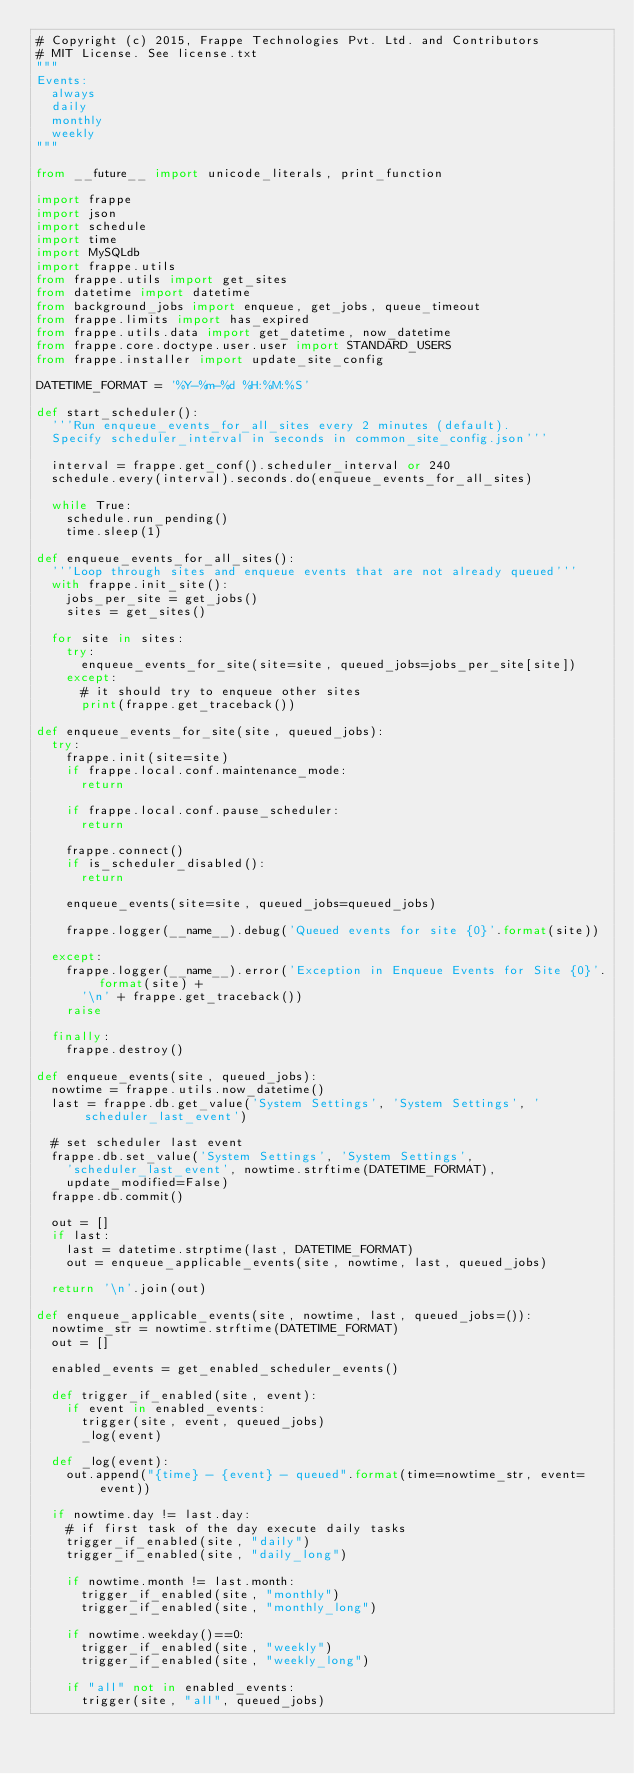<code> <loc_0><loc_0><loc_500><loc_500><_Python_># Copyright (c) 2015, Frappe Technologies Pvt. Ltd. and Contributors
# MIT License. See license.txt
"""
Events:
	always
	daily
	monthly
	weekly
"""

from __future__ import unicode_literals, print_function

import frappe
import json
import schedule
import time
import MySQLdb
import frappe.utils
from frappe.utils import get_sites
from datetime import datetime
from background_jobs import enqueue, get_jobs, queue_timeout
from frappe.limits import has_expired
from frappe.utils.data import get_datetime, now_datetime
from frappe.core.doctype.user.user import STANDARD_USERS
from frappe.installer import update_site_config

DATETIME_FORMAT = '%Y-%m-%d %H:%M:%S'

def start_scheduler():
	'''Run enqueue_events_for_all_sites every 2 minutes (default).
	Specify scheduler_interval in seconds in common_site_config.json'''

	interval = frappe.get_conf().scheduler_interval or 240
	schedule.every(interval).seconds.do(enqueue_events_for_all_sites)

	while True:
		schedule.run_pending()
		time.sleep(1)

def enqueue_events_for_all_sites():
	'''Loop through sites and enqueue events that are not already queued'''
	with frappe.init_site():
		jobs_per_site = get_jobs()
		sites = get_sites()

	for site in sites:
		try:
			enqueue_events_for_site(site=site, queued_jobs=jobs_per_site[site])
		except:
			# it should try to enqueue other sites
			print(frappe.get_traceback())

def enqueue_events_for_site(site, queued_jobs):
	try:
		frappe.init(site=site)
		if frappe.local.conf.maintenance_mode:
			return

		if frappe.local.conf.pause_scheduler:
			return

		frappe.connect()
		if is_scheduler_disabled():
			return

		enqueue_events(site=site, queued_jobs=queued_jobs)

		frappe.logger(__name__).debug('Queued events for site {0}'.format(site))

	except:
		frappe.logger(__name__).error('Exception in Enqueue Events for Site {0}'.format(site) +
			'\n' + frappe.get_traceback())
		raise

	finally:
		frappe.destroy()

def enqueue_events(site, queued_jobs):
	nowtime = frappe.utils.now_datetime()
	last = frappe.db.get_value('System Settings', 'System Settings', 'scheduler_last_event')

	# set scheduler last event
	frappe.db.set_value('System Settings', 'System Settings',
		'scheduler_last_event', nowtime.strftime(DATETIME_FORMAT),
		update_modified=False)
	frappe.db.commit()

	out = []
	if last:
		last = datetime.strptime(last, DATETIME_FORMAT)
		out = enqueue_applicable_events(site, nowtime, last, queued_jobs)

	return '\n'.join(out)

def enqueue_applicable_events(site, nowtime, last, queued_jobs=()):
	nowtime_str = nowtime.strftime(DATETIME_FORMAT)
	out = []

	enabled_events = get_enabled_scheduler_events()

	def trigger_if_enabled(site, event):
		if event in enabled_events:
			trigger(site, event, queued_jobs)
			_log(event)

	def _log(event):
		out.append("{time} - {event} - queued".format(time=nowtime_str, event=event))

	if nowtime.day != last.day:
		# if first task of the day execute daily tasks
		trigger_if_enabled(site, "daily")
		trigger_if_enabled(site, "daily_long")

		if nowtime.month != last.month:
			trigger_if_enabled(site, "monthly")
			trigger_if_enabled(site, "monthly_long")

		if nowtime.weekday()==0:
			trigger_if_enabled(site, "weekly")
			trigger_if_enabled(site, "weekly_long")

		if "all" not in enabled_events:
			trigger(site, "all", queued_jobs)
</code> 